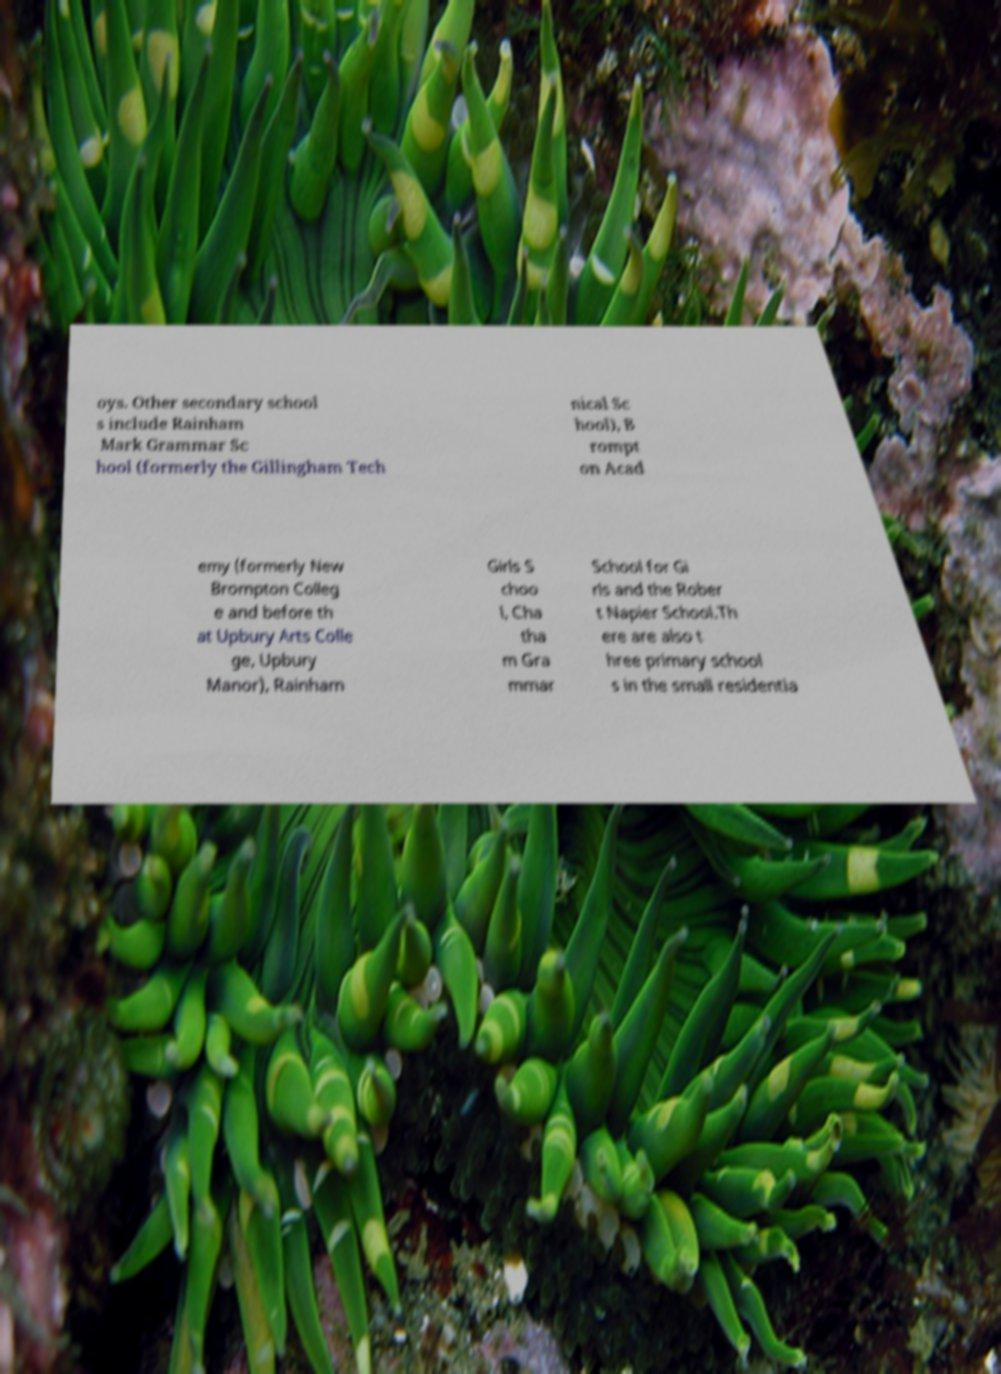I need the written content from this picture converted into text. Can you do that? oys. Other secondary school s include Rainham Mark Grammar Sc hool (formerly the Gillingham Tech nical Sc hool), B rompt on Acad emy (formerly New Brompton Colleg e and before th at Upbury Arts Colle ge, Upbury Manor), Rainham Girls S choo l, Cha tha m Gra mmar School for Gi rls and the Rober t Napier School.Th ere are also t hree primary school s in the small residentia 